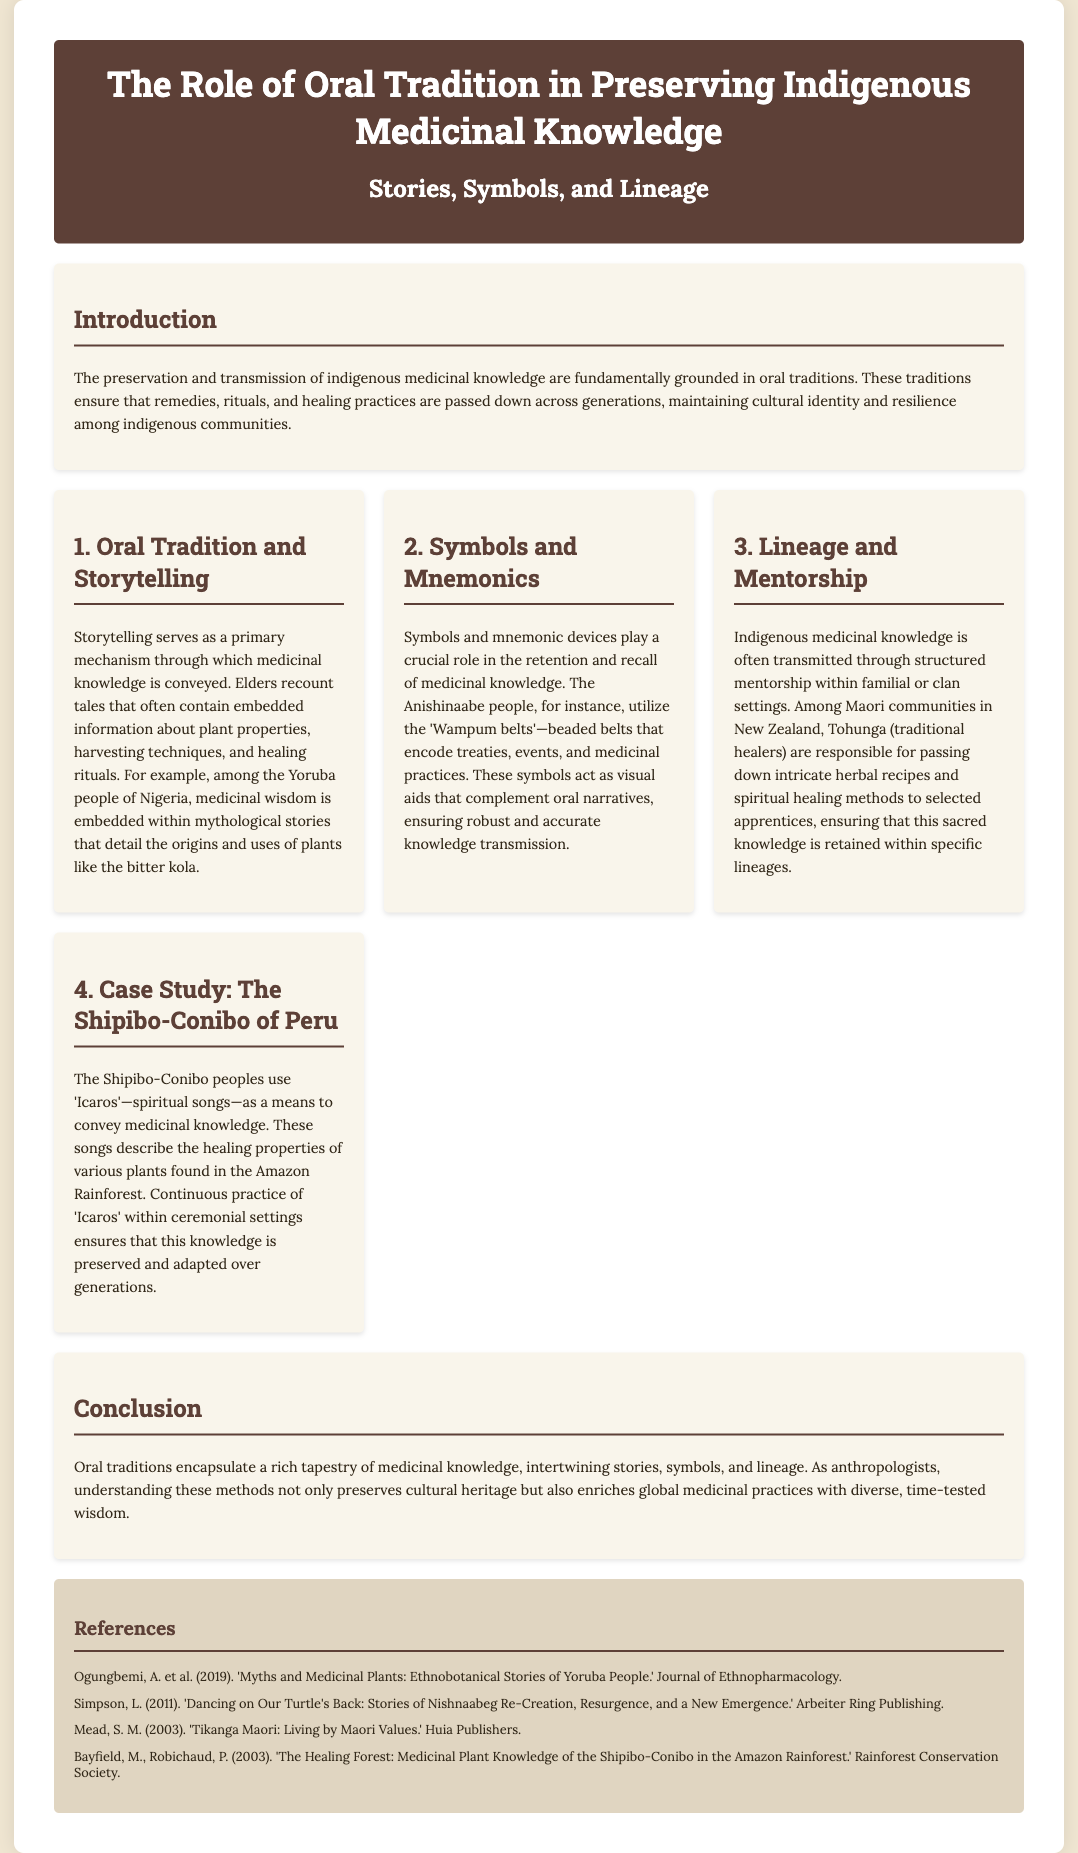what is the title of the poster? The title of the poster is prominently displayed at the top.
Answer: The Role of Oral Tradition in Preserving Indigenous Medicinal Knowledge who are responsible for passing down medicinal knowledge among Maori communities? The document mentions the specific role of certain individuals within Maori communities.
Answer: Tohunga what is the primary mechanism of conveying medicinal knowledge among indigenous cultures? The document explains the main method used for this purpose in the introduction.
Answer: Storytelling which group utilizes 'Wampum belts' for retaining medicinal knowledge? This detail is highlighted in the section discussing symbols and mnemonics.
Answer: Anishinaabe people what are the 'Icaros' used by the Shipibo-Conibo peoples? The document describes these as part of a case study in preserving medicinal knowledge.
Answer: Spiritual songs what is the purpose of storytelling in indigenous medicinal knowledge? The document states the function of storytelling in the specific section about oral tradition.
Answer: To convey medicinal knowledge how many references are listed in the document? The total count of references can be found at the end of the poster.
Answer: Four which community is mentioned regarding the use of spiritual songs for knowledge transmission? This specific community is discussed in connection with a case study in the document.
Answer: Shipibo-Conibo 